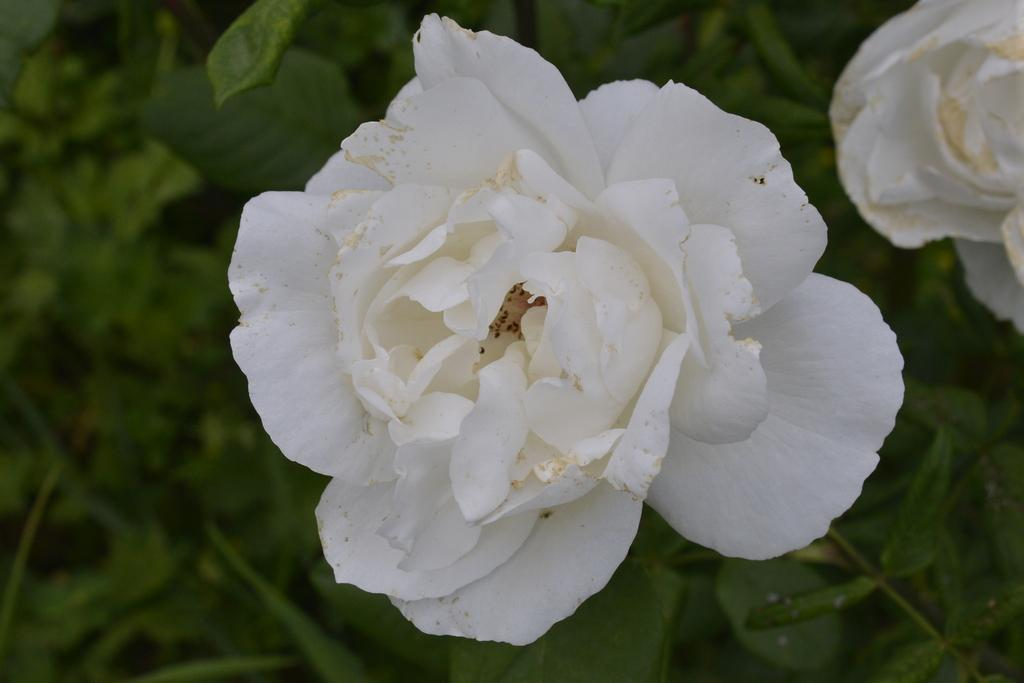What type of flowers can be seen in the image? There are two white color flowers in the image. What else is visible in the background of the image? There are leaves in the background of the image. Can you describe the flowers' appearance? The petals of the flowers are visible. What type of notebook is being used to write a dinner menu in the image? There is no notebook or dinner menu present in the image; it features two white color flowers and leaves in the background. 